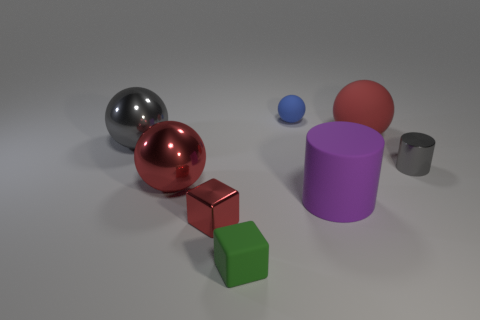Subtract 1 balls. How many balls are left? 3 Add 2 blue shiny things. How many objects exist? 10 Subtract all cylinders. How many objects are left? 6 Subtract all large blue metallic things. Subtract all tiny blocks. How many objects are left? 6 Add 8 small blocks. How many small blocks are left? 10 Add 7 small gray shiny spheres. How many small gray shiny spheres exist? 7 Subtract 1 gray balls. How many objects are left? 7 